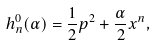Convert formula to latex. <formula><loc_0><loc_0><loc_500><loc_500>h _ { n } ^ { 0 } ( \alpha ) = \frac { 1 } { 2 } p ^ { 2 } + \frac { \alpha } { 2 } x ^ { n } ,</formula> 